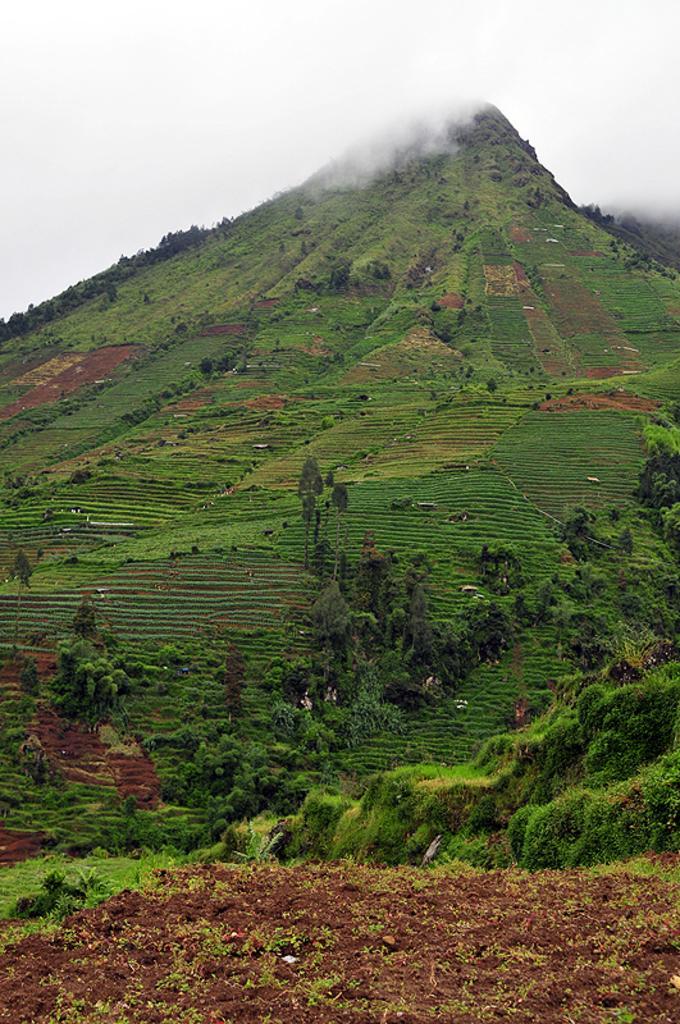Please provide a concise description of this image. In this image we can see a hill that includes greenery, plants and sand. 